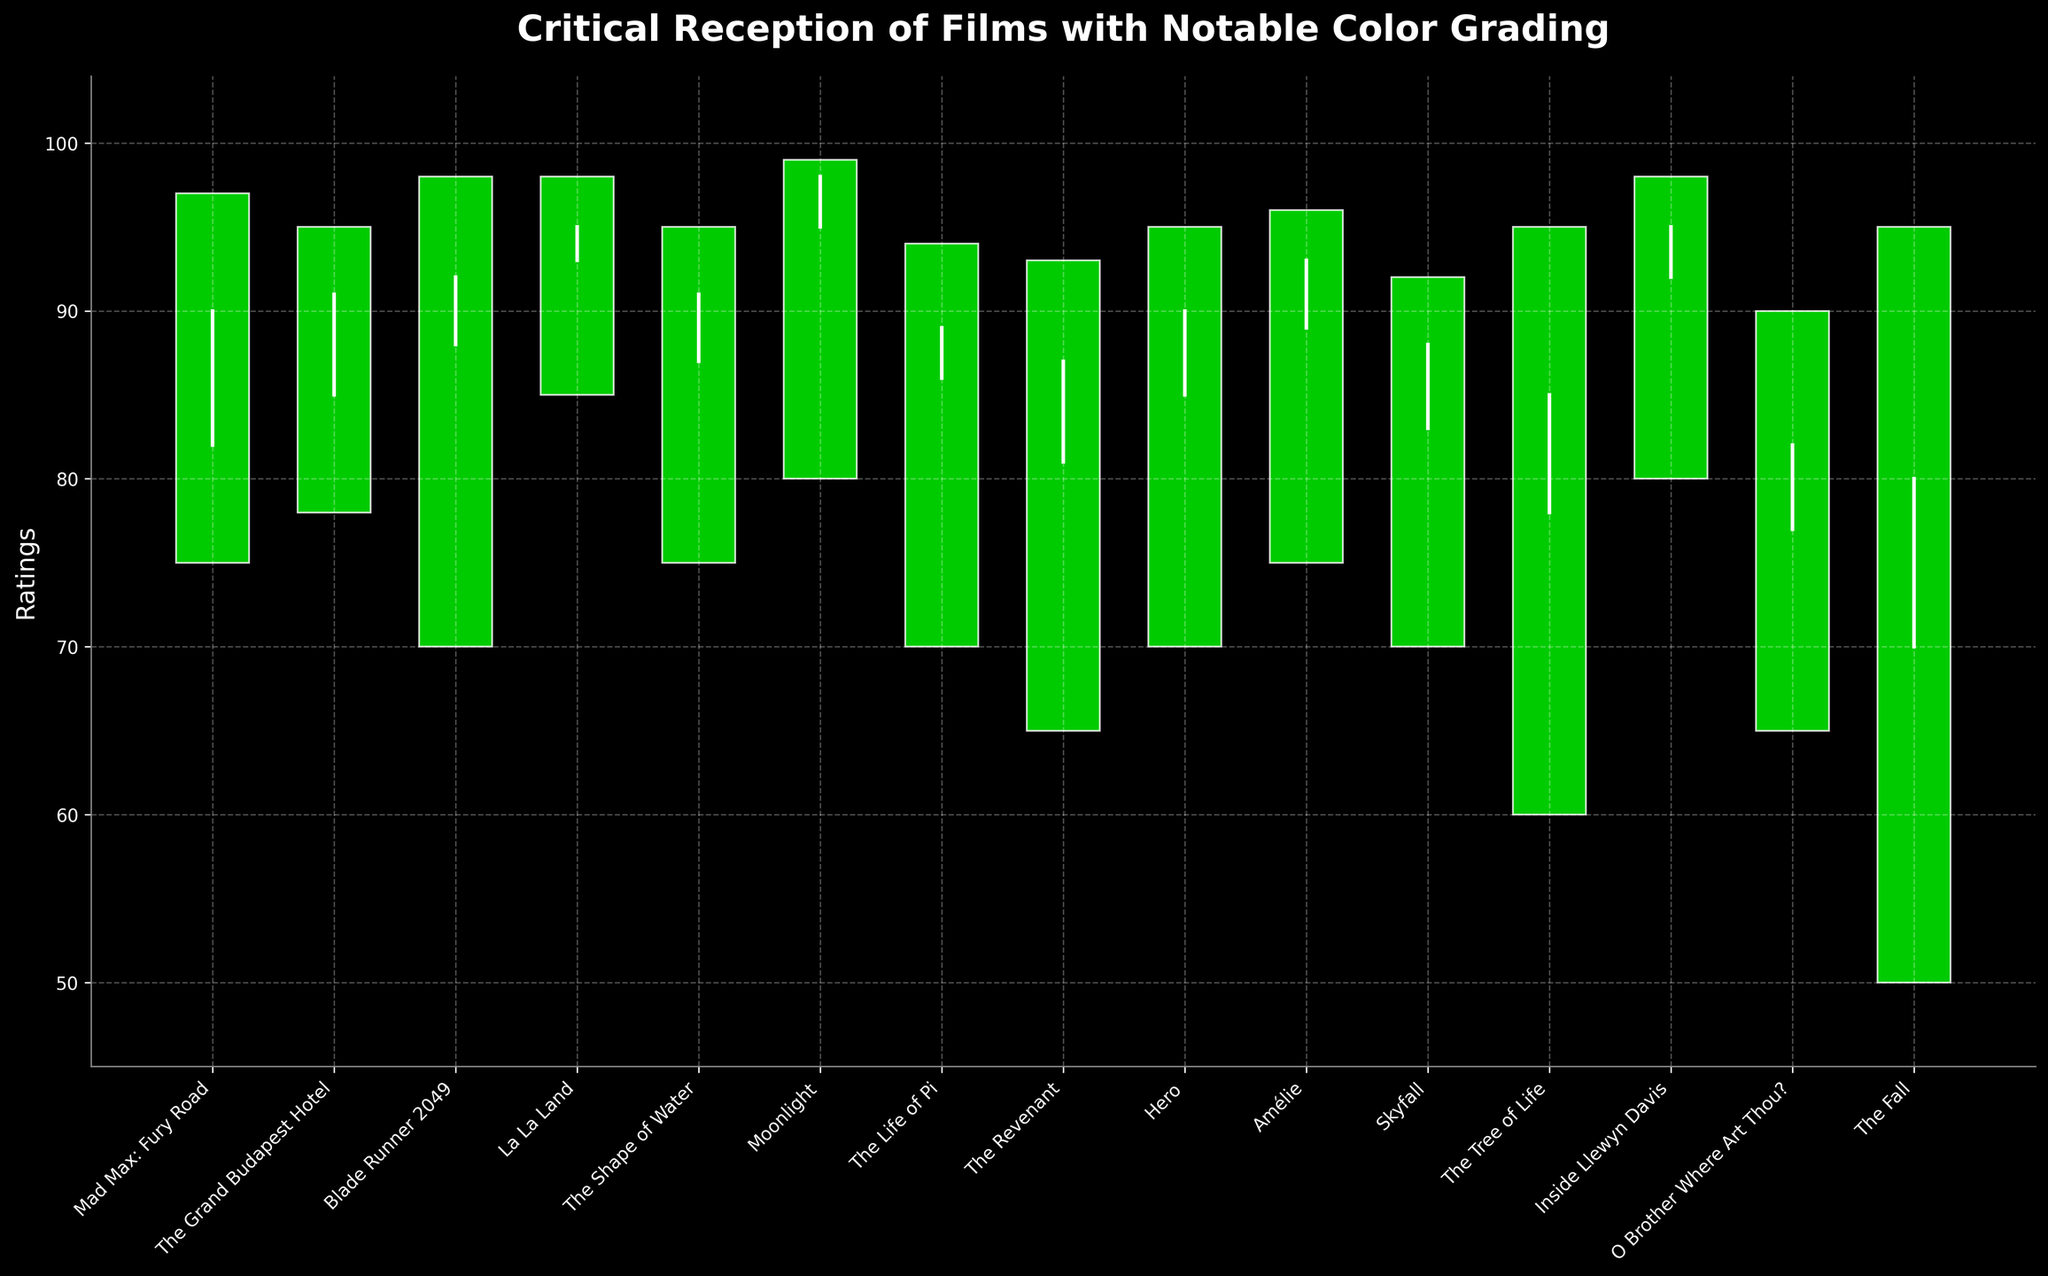What is the title of the figure? The title of the figure is displayed at the top of the chart in large, bold font. It usually titles the overall content or theme of the plot.
Answer: Critical Reception of Films with Notable Color Grading How many films are depicted in the figure? The number of films can be determined by counting the x-axis labels, each corresponding to a film title.
Answer: 15 Which film received the highest final consensus score? To find the film with the highest final consensus score, look for the highest position among the closing points represented by the white line crossing the rectangle.
Answer: Moonlight What is the initial review score for "La La Land"? To find the initial review score, locate the film "La La Land" along the x-axis and look at the starting point of the white line (which is the vertical white line drawn from initial to final score).
Answer: 93 What is the lowest rating for "The Tree of Life"? To find the lowest rating, look for the bottom of the green/red rectangle associated with "The Tree of Life" on the x-axis. The bottom of the rectangle represents the lowest rating.
Answer: 60 Which two films have the greatest difference between the highest and lowest ratings? Calculate the difference between the highest and lowest ratings for each film and find the two films with the largest differences. "The Fall" has a difference of 45 (95-50), and "The Tree of Life" has a difference of 35 (95-60). These are the two films with the greatest differences.
Answer: The Fall and The Tree of Life Which film had a final consensus score lower than its initial review score? Identify films where the closing point (final consensus) is lower than the opening point (initial review) on the white vertical line. For this figure, no film has such a condition since all green/red rectangles close higher or equal to opening.
Answer: None What is the average of the highest ratings among all the films? Summing up the highest ratings for all the films (97 + 95 + 98 + 98 + 95 + 99 + 94 + 93 + 95 + 96 + 92 + 95 + 98 + 90 + 95) gives 1326. The average is 1326 / 15.
Answer: 88.4 Which film had the closest final consensus score to its initial review score? Calculate the absolute difference between the initial review and final consensus for each film and find the smallest difference. For "Hero" it’s 85 - 90 = 5; look at other films and same logic is applied - "Amélie" 89 - 93 = 4.
Answer: Amélie 